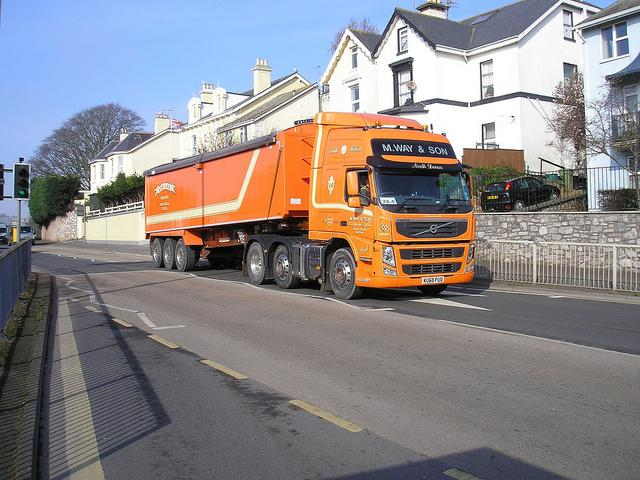What type of truck is this? semi 